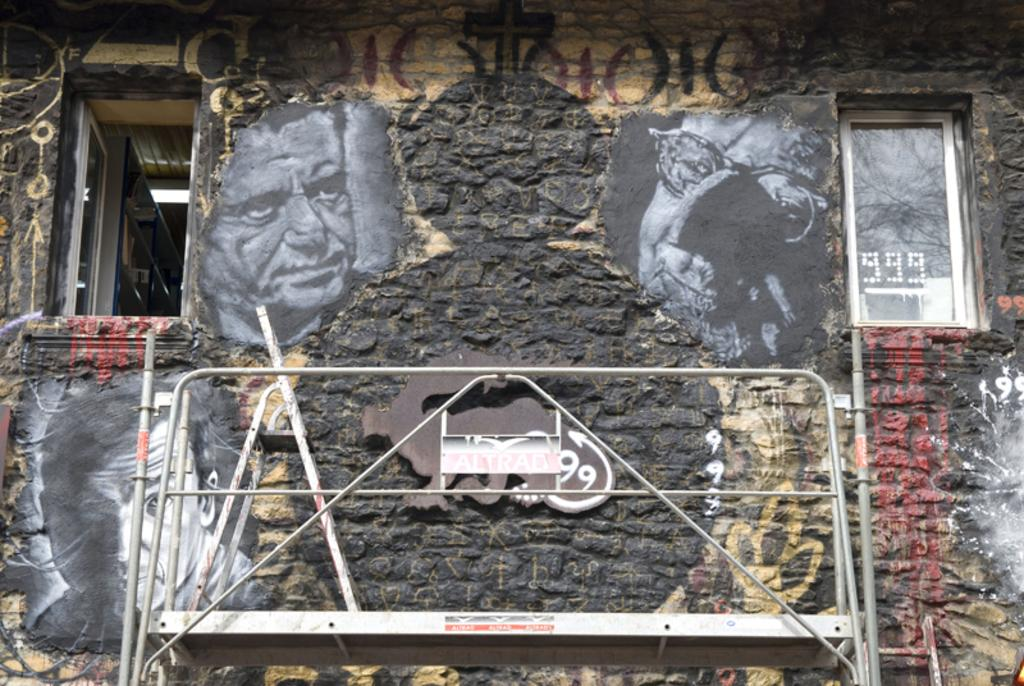What structure is located at the bottom of the image? There is a metal stand at the bottom of the image. What can be seen in the background of the image? There is a wall in the background of the image. What is depicted on the wall? Paintings of persons are visible on the wall. How many windows are present in the image? There are two windows, one on the right side and one on the left side of the image. Can you tell me how many berries are on the windowsill in the image? There are no berries present in the image; it features a metal stand, a wall with paintings, and two windows. What type of toy is depicted in the painting on the wall? There is no toy depicted in the painting on the wall; the paintings feature persons. 